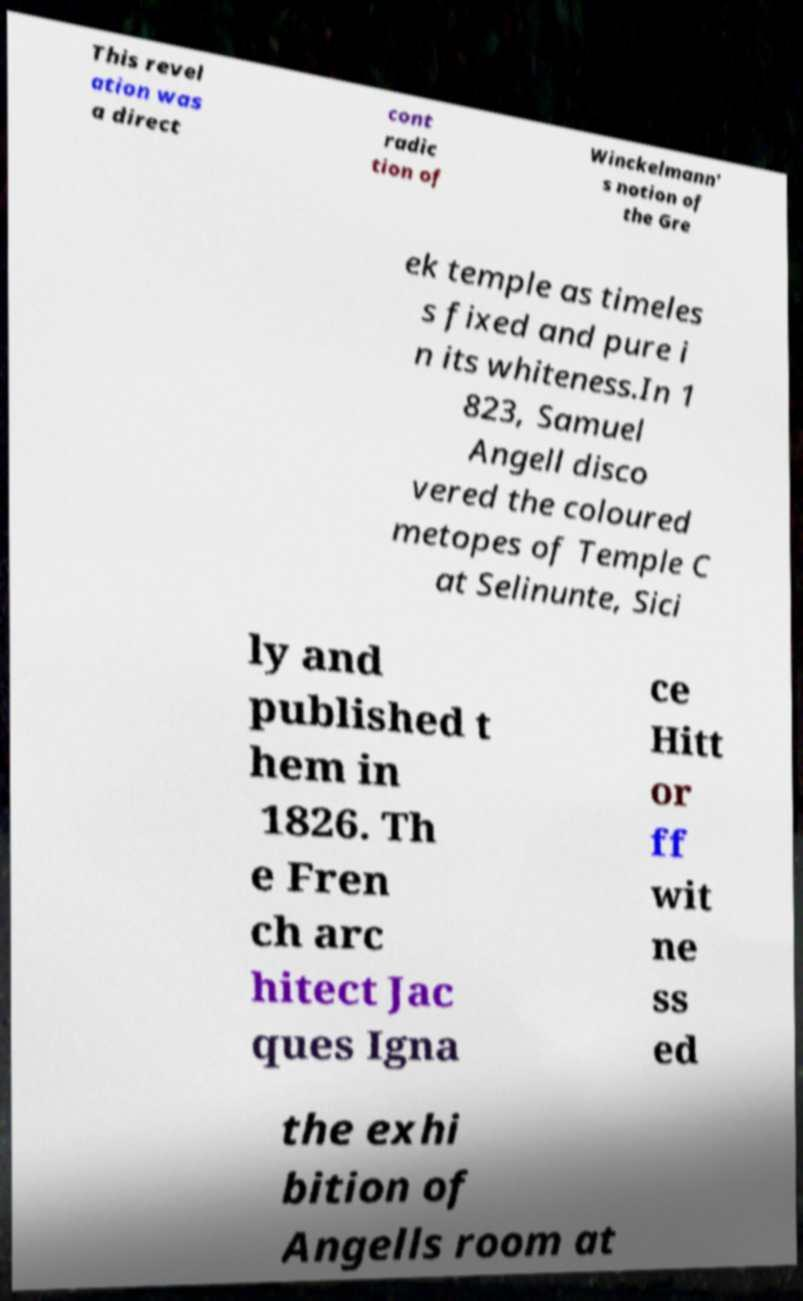Could you extract and type out the text from this image? This revel ation was a direct cont radic tion of Winckelmann' s notion of the Gre ek temple as timeles s fixed and pure i n its whiteness.In 1 823, Samuel Angell disco vered the coloured metopes of Temple C at Selinunte, Sici ly and published t hem in 1826. Th e Fren ch arc hitect Jac ques Igna ce Hitt or ff wit ne ss ed the exhi bition of Angells room at 